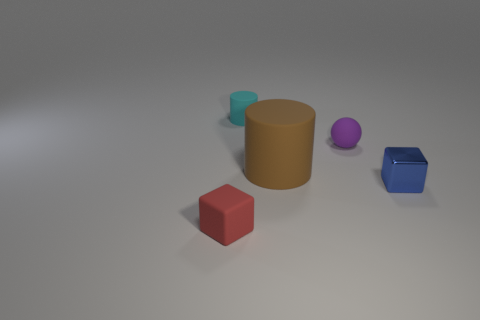Subtract all blue balls. Subtract all gray cylinders. How many balls are left? 1 Subtract all cyan balls. How many yellow cubes are left? 0 Add 1 large browns. How many small things exist? 0 Subtract all cubes. Subtract all large cyan blocks. How many objects are left? 3 Add 5 large brown matte cylinders. How many large brown matte cylinders are left? 6 Add 5 small cyan cubes. How many small cyan cubes exist? 5 Add 5 tiny red matte cubes. How many objects exist? 10 Subtract all red cubes. How many cubes are left? 1 Subtract 0 yellow balls. How many objects are left? 5 Subtract all cylinders. How many objects are left? 3 